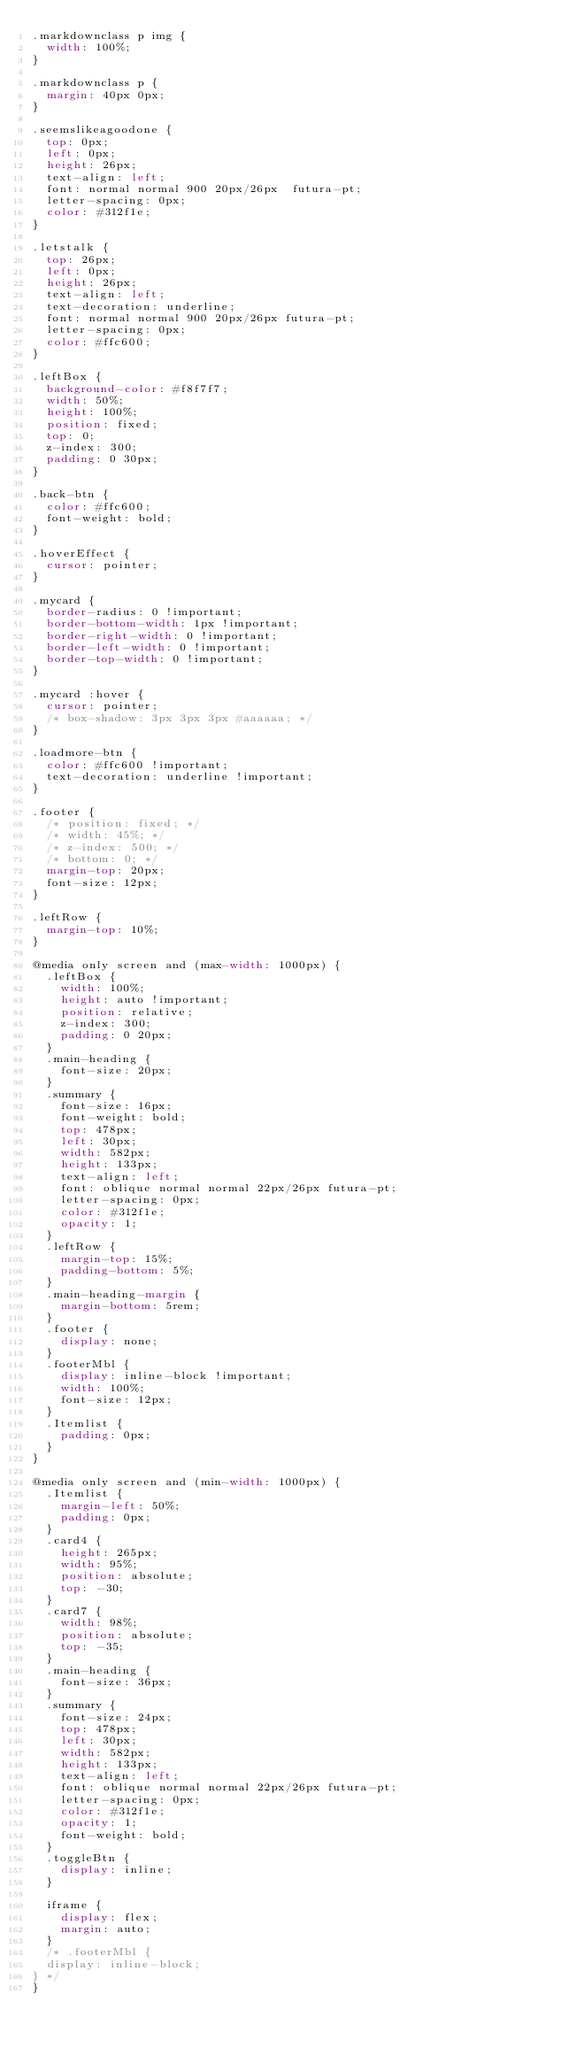Convert code to text. <code><loc_0><loc_0><loc_500><loc_500><_CSS_>.markdownclass p img {
  width: 100%;
}

.markdownclass p {
  margin: 40px 0px;
}

.seemslikeagoodone {
  top: 0px;
  left: 0px;
  height: 26px;
  text-align: left;
  font: normal normal 900 20px/26px  futura-pt;
  letter-spacing: 0px;
  color: #312f1e;
}

.letstalk {
  top: 26px;
  left: 0px;
  height: 26px;
  text-align: left;
  text-decoration: underline;
  font: normal normal 900 20px/26px futura-pt;
  letter-spacing: 0px;
  color: #ffc600;
}

.leftBox {
  background-color: #f8f7f7;
  width: 50%;
  height: 100%;
  position: fixed;
  top: 0;
  z-index: 300;
  padding: 0 30px;
}

.back-btn {
  color: #ffc600;
  font-weight: bold;
}

.hoverEffect {
  cursor: pointer;
}

.mycard {
  border-radius: 0 !important;
  border-bottom-width: 1px !important;
  border-right-width: 0 !important;
  border-left-width: 0 !important;
  border-top-width: 0 !important;
}

.mycard :hover {
  cursor: pointer;
  /* box-shadow: 3px 3px 3px #aaaaaa; */
}

.loadmore-btn {
  color: #ffc600 !important;
  text-decoration: underline !important;
}

.footer {
  /* position: fixed; */
  /* width: 45%; */
  /* z-index: 500; */
  /* bottom: 0; */
  margin-top: 20px;
  font-size: 12px;
}

.leftRow {
  margin-top: 10%;
}

@media only screen and (max-width: 1000px) {
  .leftBox {
    width: 100%;
    height: auto !important;
    position: relative;
    z-index: 300;
    padding: 0 20px;
  }
  .main-heading {
    font-size: 20px;
  }
  .summary {
    font-size: 16px;
    font-weight: bold;
    top: 478px;
    left: 30px;
    width: 582px;
    height: 133px;
    text-align: left;
    font: oblique normal normal 22px/26px futura-pt;
    letter-spacing: 0px;
    color: #312f1e;
    opacity: 1;
  }
  .leftRow {
    margin-top: 15%;
    padding-bottom: 5%;
  }
  .main-heading-margin {
    margin-bottom: 5rem;
  }
  .footer {
    display: none;
  }
  .footerMbl {
    display: inline-block !important;
    width: 100%;
    font-size: 12px;
  }
  .Itemlist {
    padding: 0px;
  }
}

@media only screen and (min-width: 1000px) {
  .Itemlist {
    margin-left: 50%;
    padding: 0px;
  }
  .card4 {
    height: 265px;
    width: 95%;
    position: absolute;
    top: -30;
  }
  .card7 {
    width: 98%;
    position: absolute;
    top: -35;
  }
  .main-heading {
    font-size: 36px;
  }
  .summary {
    font-size: 24px;
    top: 478px;
    left: 30px;
    width: 582px;
    height: 133px;
    text-align: left;
    font: oblique normal normal 22px/26px futura-pt;
    letter-spacing: 0px;
    color: #312f1e;
    opacity: 1;
    font-weight: bold;
  }
  .toggleBtn {
    display: inline;
  }

  iframe {
    display: flex;
    margin: auto;
  }
  /* .footerMbl {
  display: inline-block;
} */
}
</code> 